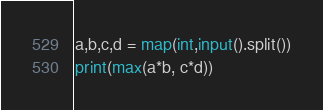<code> <loc_0><loc_0><loc_500><loc_500><_Python_>a,b,c,d = map(int,input().split())
print(max(a*b, c*d))
</code> 